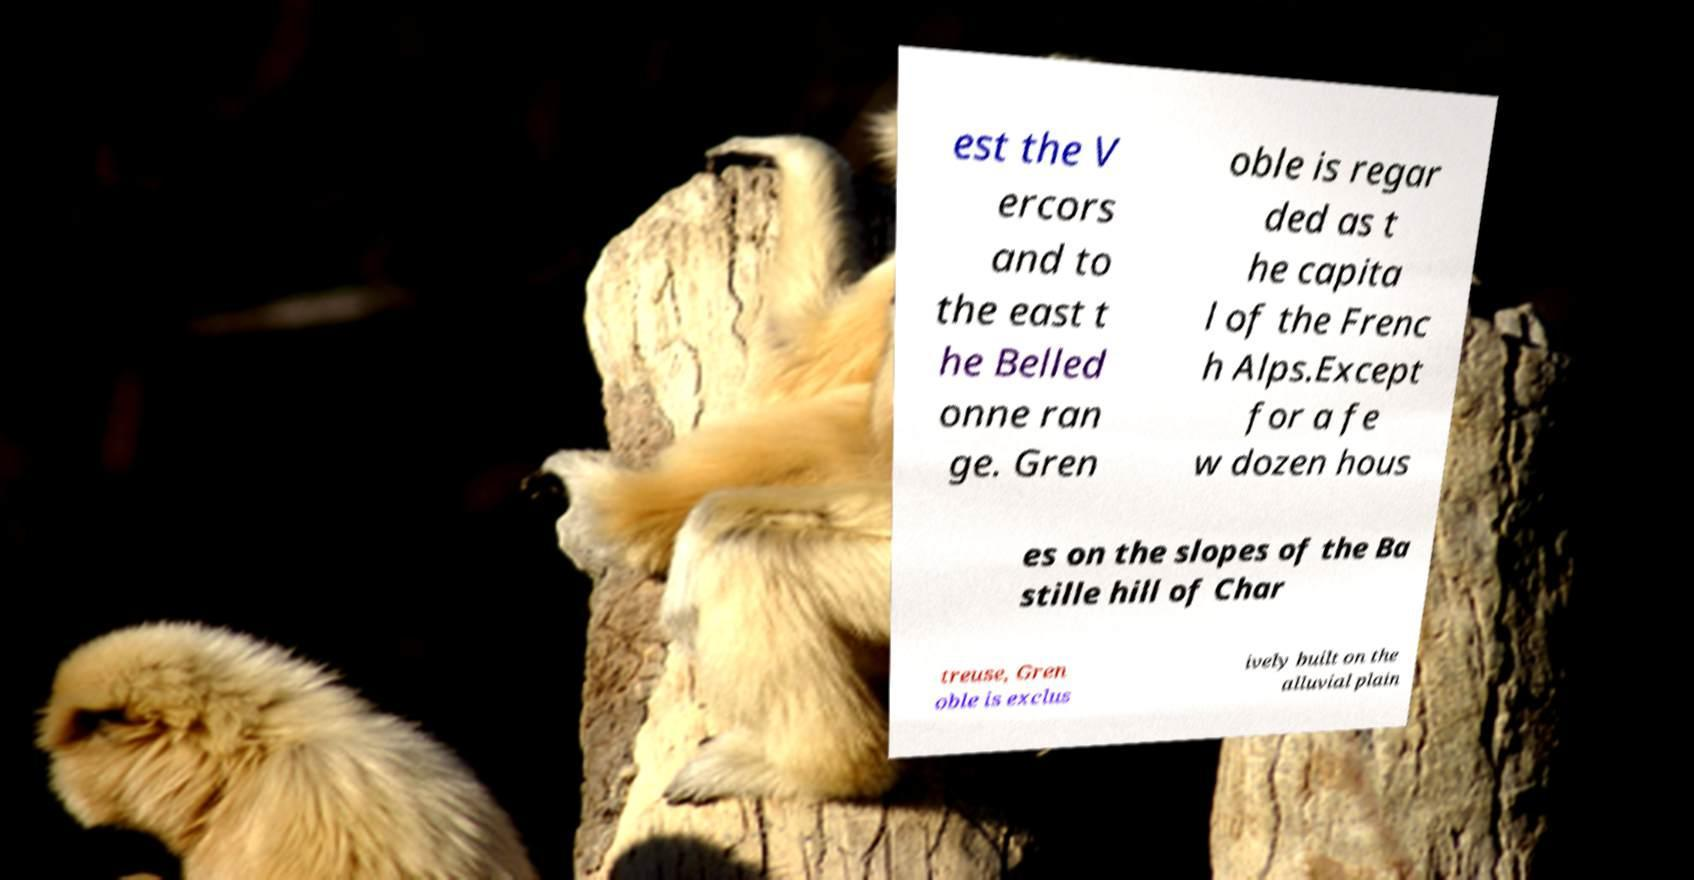There's text embedded in this image that I need extracted. Can you transcribe it verbatim? est the V ercors and to the east t he Belled onne ran ge. Gren oble is regar ded as t he capita l of the Frenc h Alps.Except for a fe w dozen hous es on the slopes of the Ba stille hill of Char treuse, Gren oble is exclus ively built on the alluvial plain 